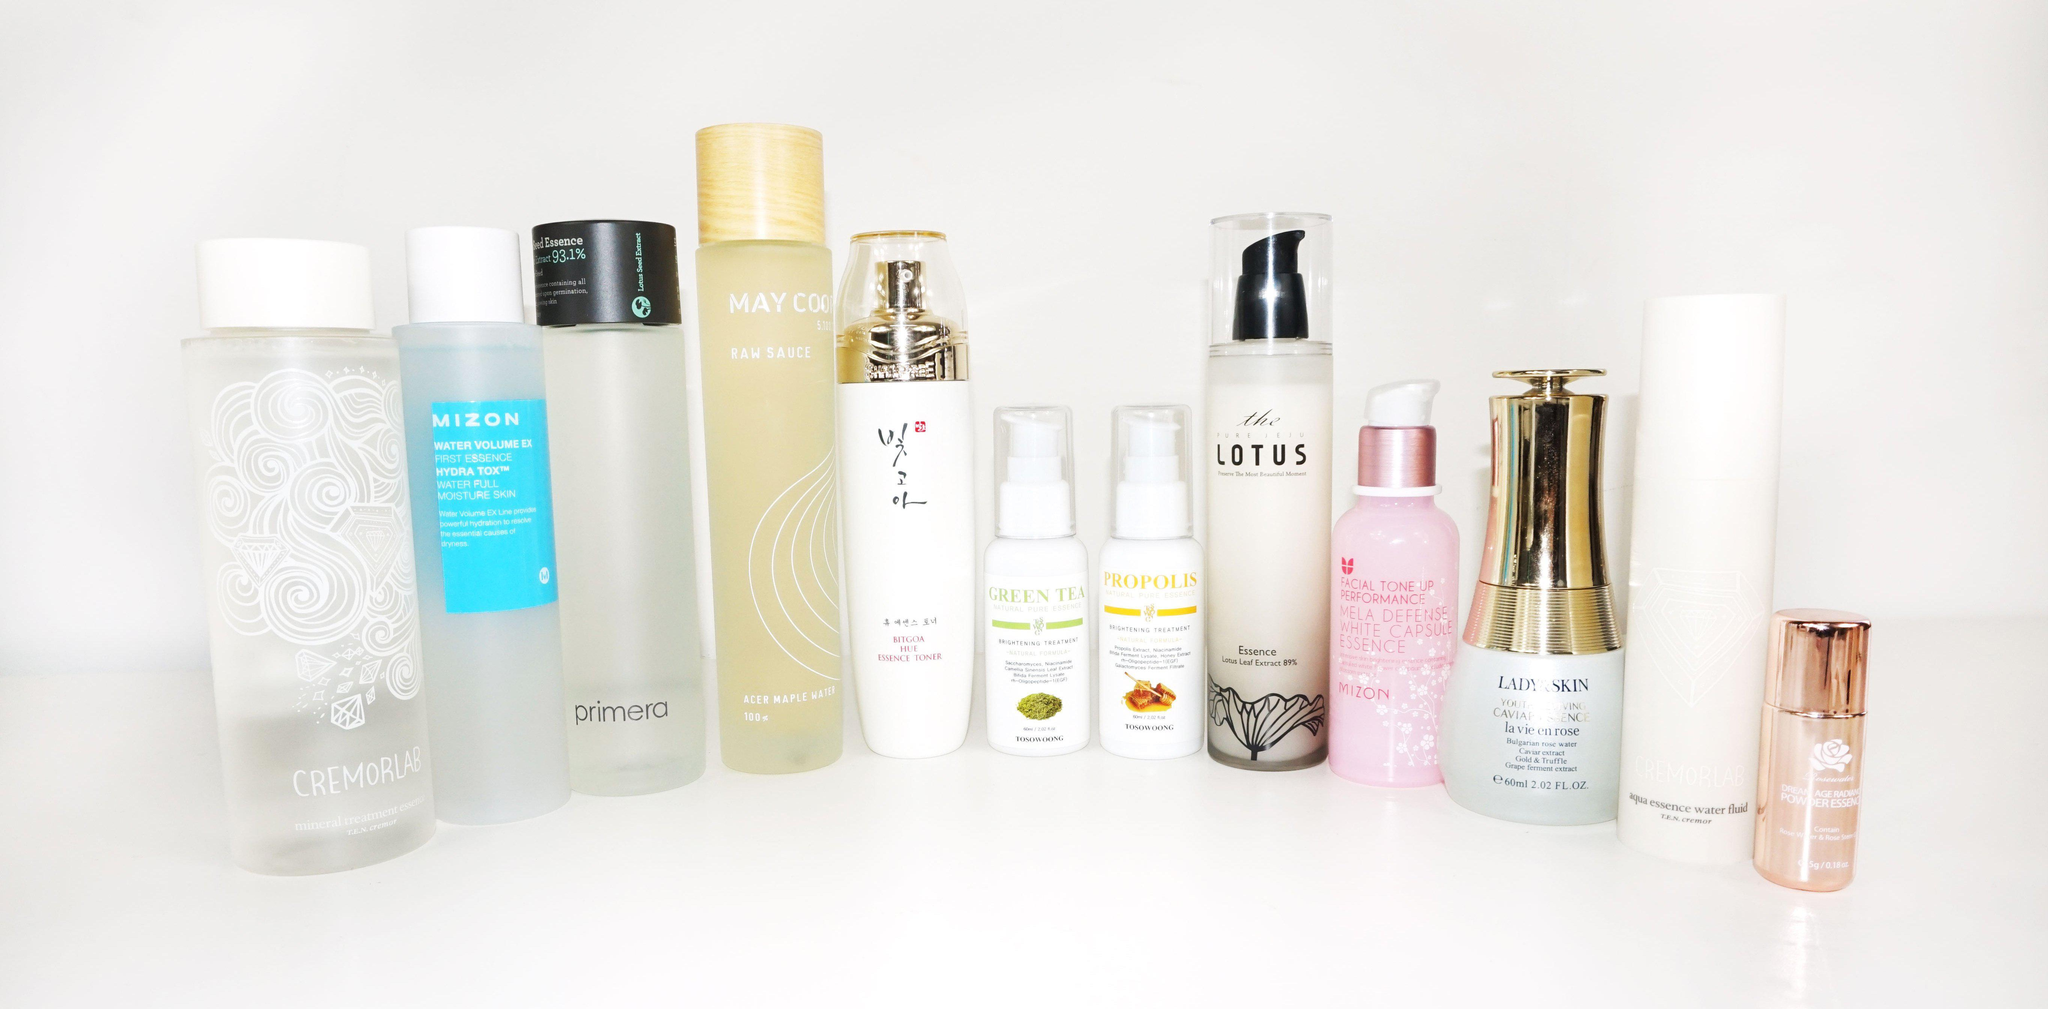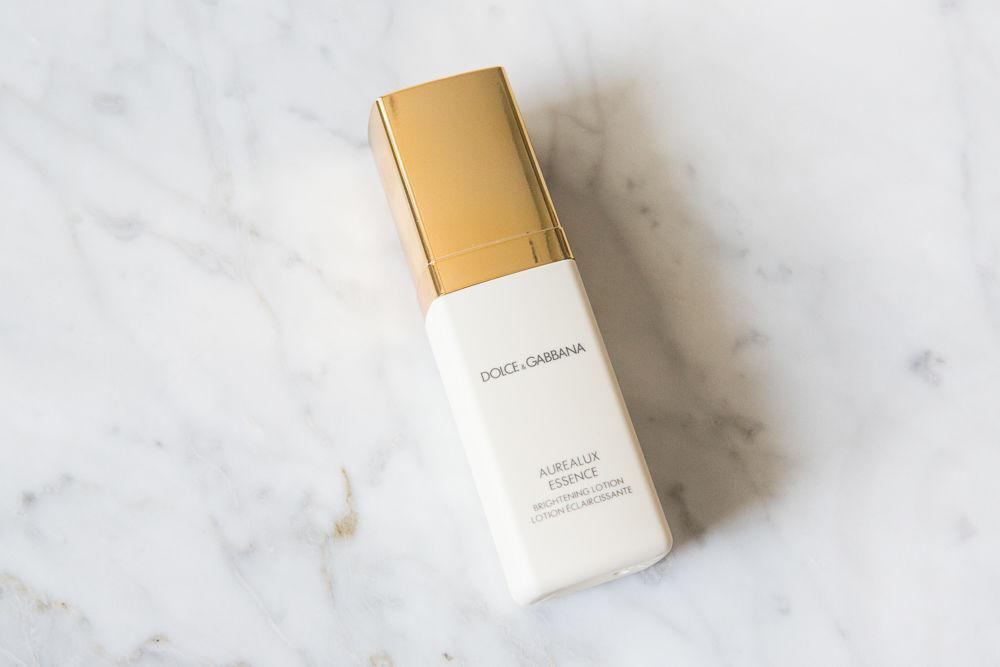The first image is the image on the left, the second image is the image on the right. Given the left and right images, does the statement "An image shows exactly one skincare product, which has a gold cap." hold true? Answer yes or no. Yes. The first image is the image on the left, the second image is the image on the right. Evaluate the accuracy of this statement regarding the images: "Four or more skin products are standing upright on a counter in the left photo.". Is it true? Answer yes or no. Yes. 